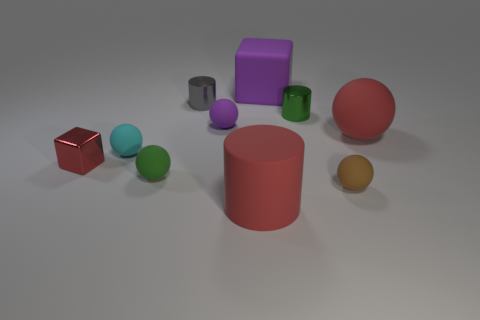There is a cyan rubber thing; does it have the same shape as the metallic object that is to the left of the gray object?
Provide a succinct answer. No. Are there any red cubes that have the same material as the big purple object?
Your answer should be very brief. No. There is a big red matte object that is behind the brown object that is in front of the purple ball; is there a small metallic thing in front of it?
Your response must be concise. Yes. How many other objects are there of the same shape as the tiny gray metal object?
Give a very brief answer. 2. The tiny shiny thing that is behind the metal cylinder that is in front of the small shiny cylinder that is behind the tiny green cylinder is what color?
Offer a terse response. Gray. What number of green objects are there?
Ensure brevity in your answer.  2. How many tiny objects are red cylinders or purple rubber balls?
Your answer should be compact. 1. The gray metal object that is the same size as the cyan rubber sphere is what shape?
Give a very brief answer. Cylinder. Is there anything else that has the same size as the metallic cube?
Your response must be concise. Yes. There is a big object in front of the red thing that is right of the red cylinder; what is its material?
Provide a succinct answer. Rubber. 